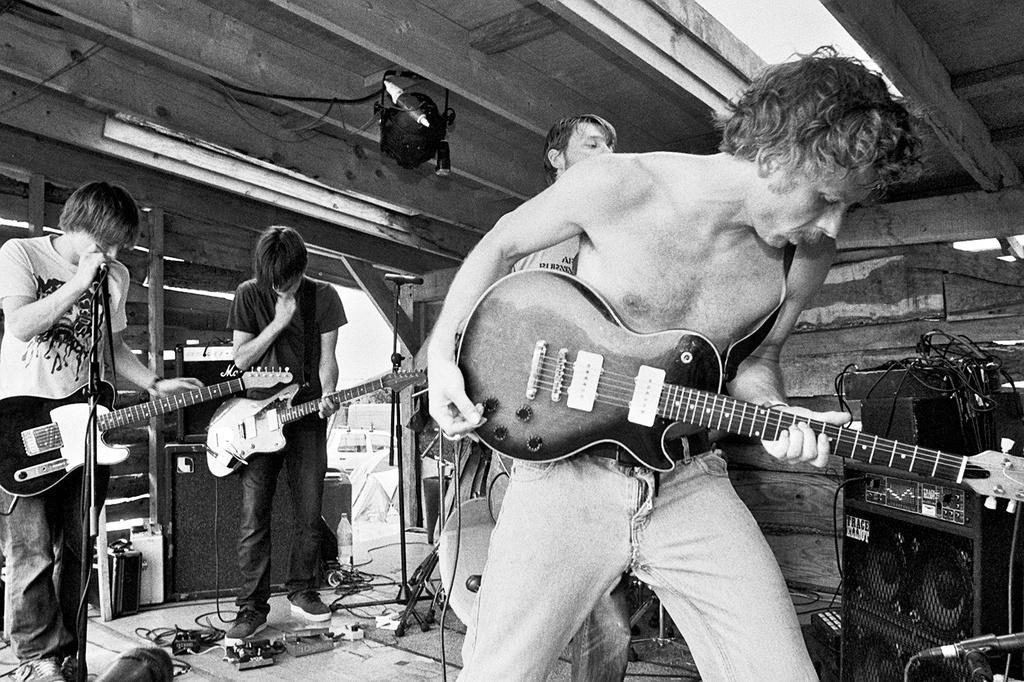In one or two sentences, can you explain what this image depicts? In this image there are four people, three people are playing guitar. At the right side of the picture there is a speaker and wires and at the bottom there are wires and at the top there is a light and at the back there is a vehicle. 